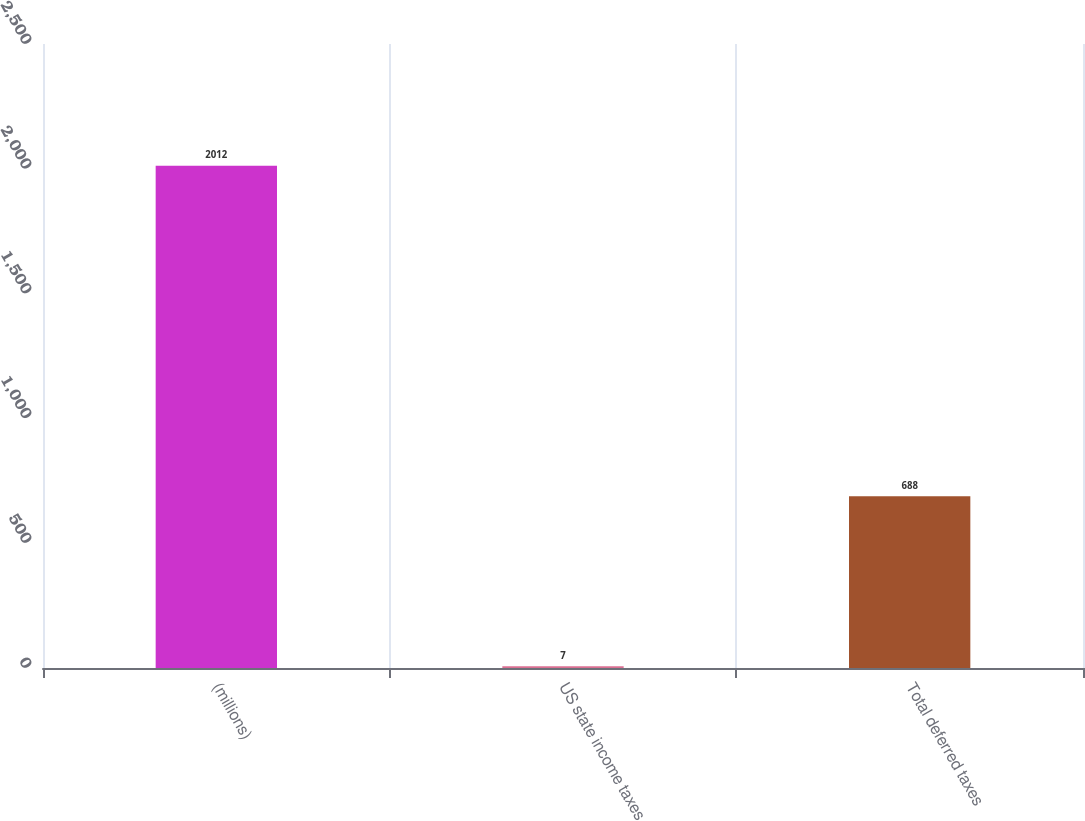<chart> <loc_0><loc_0><loc_500><loc_500><bar_chart><fcel>(millions)<fcel>US state income taxes<fcel>Total deferred taxes<nl><fcel>2012<fcel>7<fcel>688<nl></chart> 